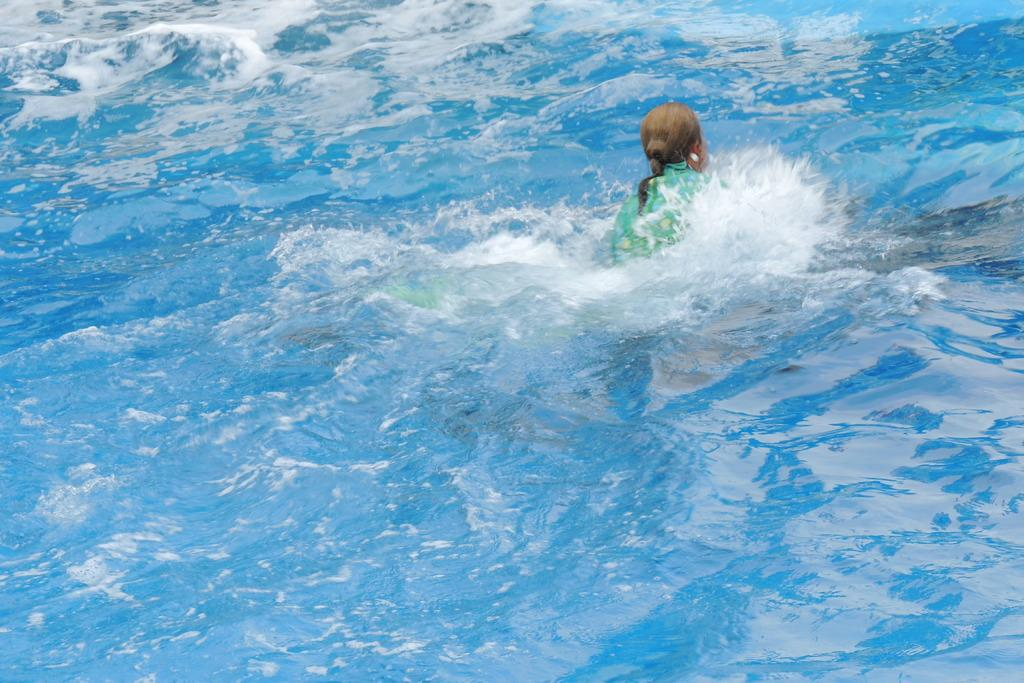What is the primary subject of the image? There is a person in the water. What type of quince is being used as a floatation device in the image? There is no quince present in the image, and therefore it cannot be used as a floatation device. 